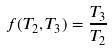Convert formula to latex. <formula><loc_0><loc_0><loc_500><loc_500>f ( T _ { 2 } , T _ { 3 } ) = \frac { T _ { 3 } } { T _ { 2 } }</formula> 